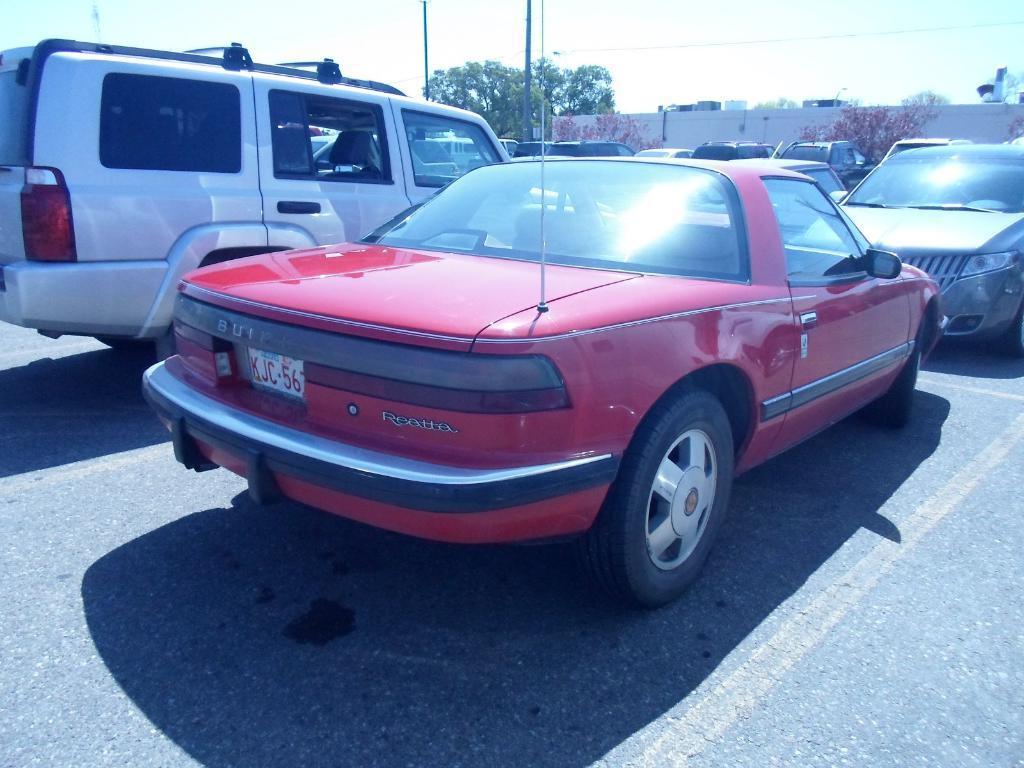Describe this image in one or two sentences. In this image I can see number of vehicles. In the background I can see few trees, a building, two poles, a wire and the sky. 